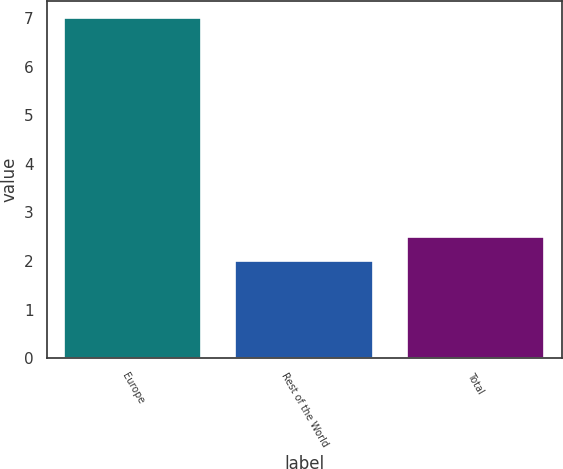Convert chart. <chart><loc_0><loc_0><loc_500><loc_500><bar_chart><fcel>Europe<fcel>Rest of the World<fcel>Total<nl><fcel>7<fcel>2<fcel>2.5<nl></chart> 